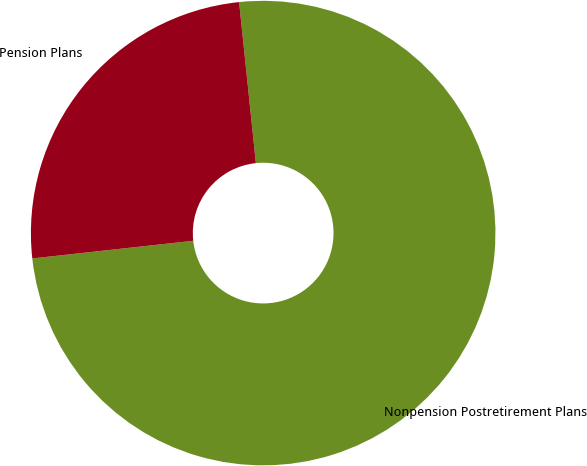Convert chart. <chart><loc_0><loc_0><loc_500><loc_500><pie_chart><fcel>Nonpension Postretirement Plans<fcel>Pension Plans<nl><fcel>74.91%<fcel>25.09%<nl></chart> 